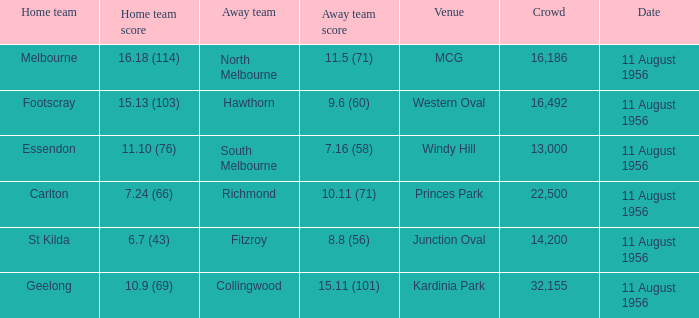18 (114)? Melbourne. 